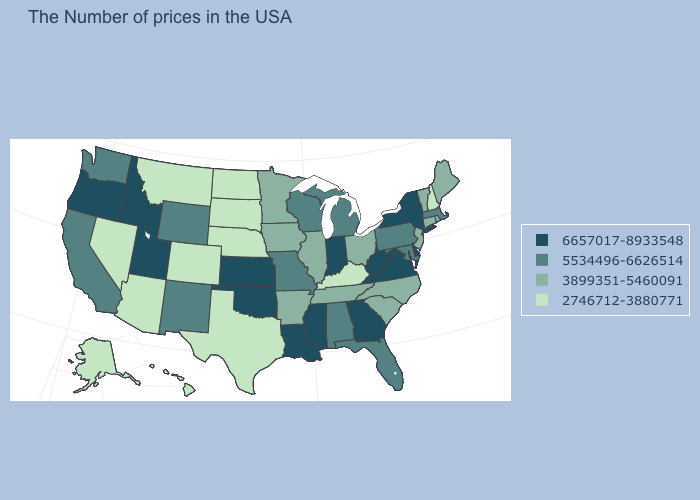Is the legend a continuous bar?
Quick response, please. No. How many symbols are there in the legend?
Concise answer only. 4. Which states have the highest value in the USA?
Quick response, please. New York, Delaware, Virginia, West Virginia, Georgia, Indiana, Mississippi, Louisiana, Kansas, Oklahoma, Utah, Idaho, Oregon. What is the value of Oklahoma?
Concise answer only. 6657017-8933548. Name the states that have a value in the range 6657017-8933548?
Answer briefly. New York, Delaware, Virginia, West Virginia, Georgia, Indiana, Mississippi, Louisiana, Kansas, Oklahoma, Utah, Idaho, Oregon. Name the states that have a value in the range 6657017-8933548?
Write a very short answer. New York, Delaware, Virginia, West Virginia, Georgia, Indiana, Mississippi, Louisiana, Kansas, Oklahoma, Utah, Idaho, Oregon. How many symbols are there in the legend?
Give a very brief answer. 4. Does Vermont have a lower value than Michigan?
Give a very brief answer. Yes. Name the states that have a value in the range 3899351-5460091?
Short answer required. Maine, Rhode Island, Vermont, Connecticut, New Jersey, North Carolina, South Carolina, Ohio, Tennessee, Illinois, Arkansas, Minnesota, Iowa. What is the value of Oklahoma?
Give a very brief answer. 6657017-8933548. Does Nevada have a lower value than Texas?
Quick response, please. No. Name the states that have a value in the range 3899351-5460091?
Short answer required. Maine, Rhode Island, Vermont, Connecticut, New Jersey, North Carolina, South Carolina, Ohio, Tennessee, Illinois, Arkansas, Minnesota, Iowa. Does Tennessee have a higher value than Alaska?
Concise answer only. Yes. Which states have the lowest value in the West?
Give a very brief answer. Colorado, Montana, Arizona, Nevada, Alaska, Hawaii. Which states hav the highest value in the Northeast?
Give a very brief answer. New York. 